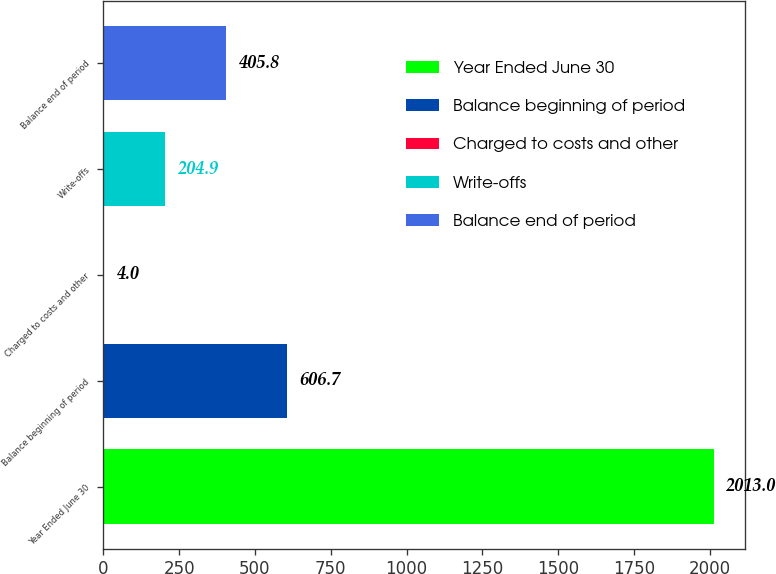Convert chart. <chart><loc_0><loc_0><loc_500><loc_500><bar_chart><fcel>Year Ended June 30<fcel>Balance beginning of period<fcel>Charged to costs and other<fcel>Write-offs<fcel>Balance end of period<nl><fcel>2013<fcel>606.7<fcel>4<fcel>204.9<fcel>405.8<nl></chart> 